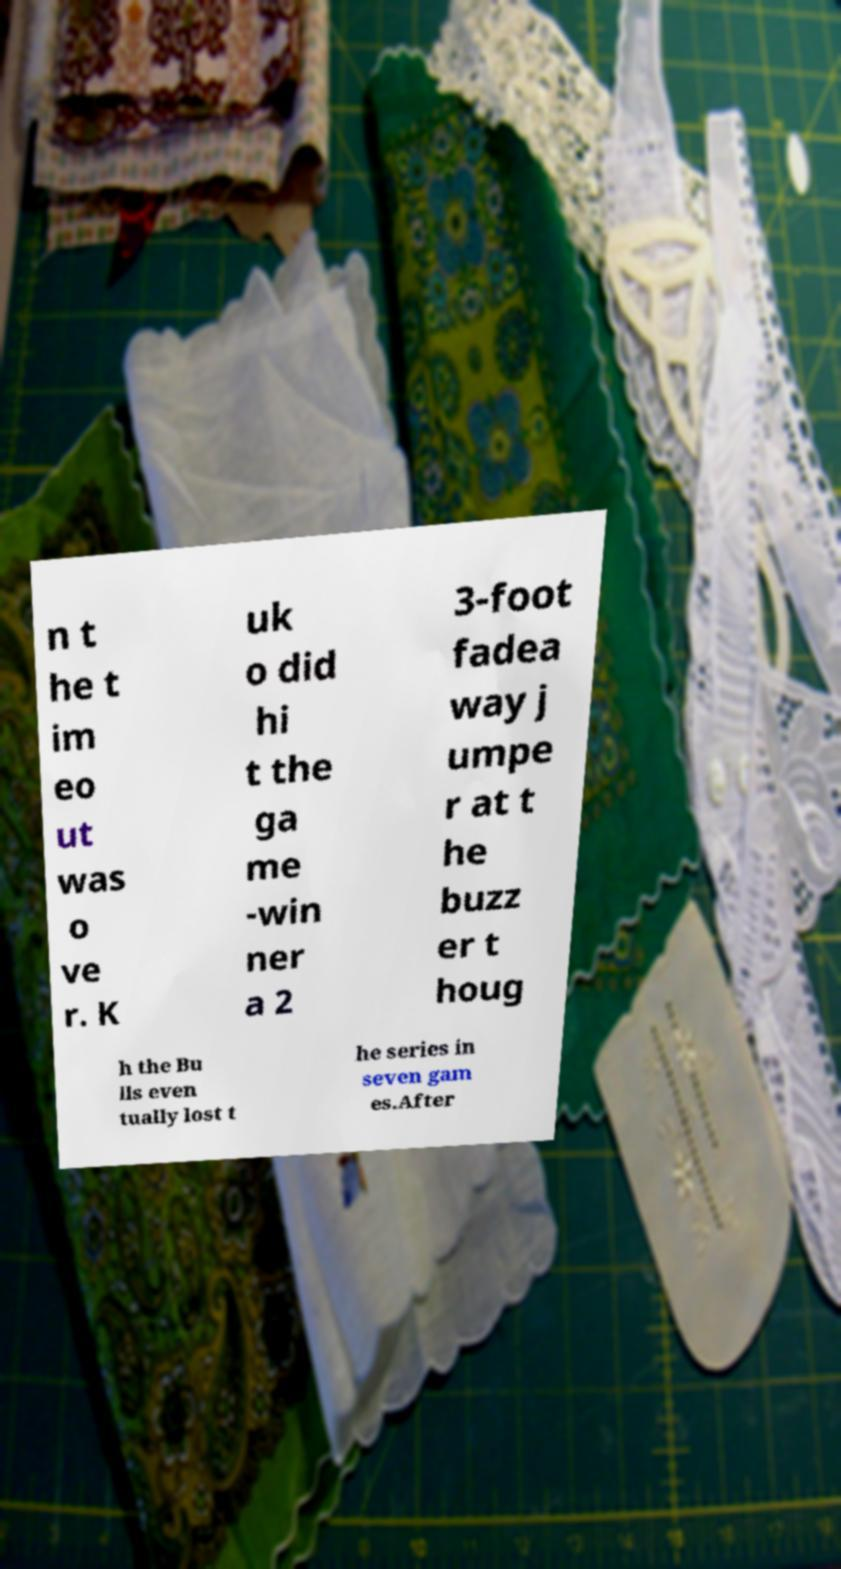Please read and relay the text visible in this image. What does it say? n t he t im eo ut was o ve r. K uk o did hi t the ga me -win ner a 2 3-foot fadea way j umpe r at t he buzz er t houg h the Bu lls even tually lost t he series in seven gam es.After 